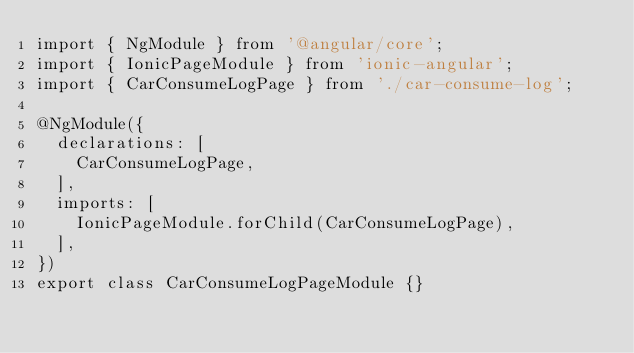Convert code to text. <code><loc_0><loc_0><loc_500><loc_500><_TypeScript_>import { NgModule } from '@angular/core';
import { IonicPageModule } from 'ionic-angular';
import { CarConsumeLogPage } from './car-consume-log';

@NgModule({
  declarations: [
    CarConsumeLogPage,
  ],
  imports: [
    IonicPageModule.forChild(CarConsumeLogPage),
  ],
})
export class CarConsumeLogPageModule {}
</code> 